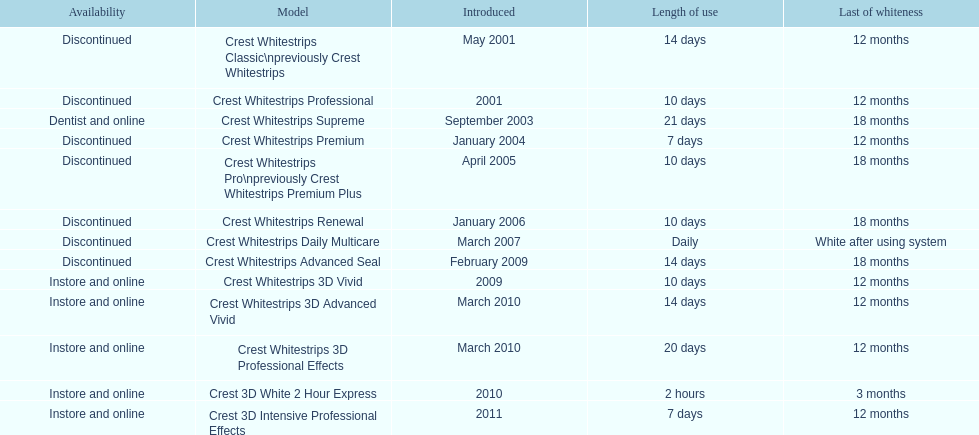Which of these products are discontinued? Crest Whitestrips Classic\npreviously Crest Whitestrips, Crest Whitestrips Professional, Crest Whitestrips Premium, Crest Whitestrips Pro\npreviously Crest Whitestrips Premium Plus, Crest Whitestrips Renewal, Crest Whitestrips Daily Multicare, Crest Whitestrips Advanced Seal. Which of these products have a 14 day length of use? Crest Whitestrips Classic\npreviously Crest Whitestrips, Crest Whitestrips Advanced Seal. Which of these products was introduced in 2009? Crest Whitestrips Advanced Seal. 